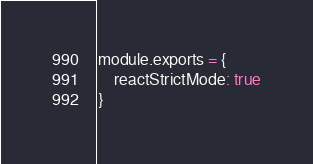Convert code to text. <code><loc_0><loc_0><loc_500><loc_500><_JavaScript_>module.exports = {
    reactStrictMode: true
}</code> 